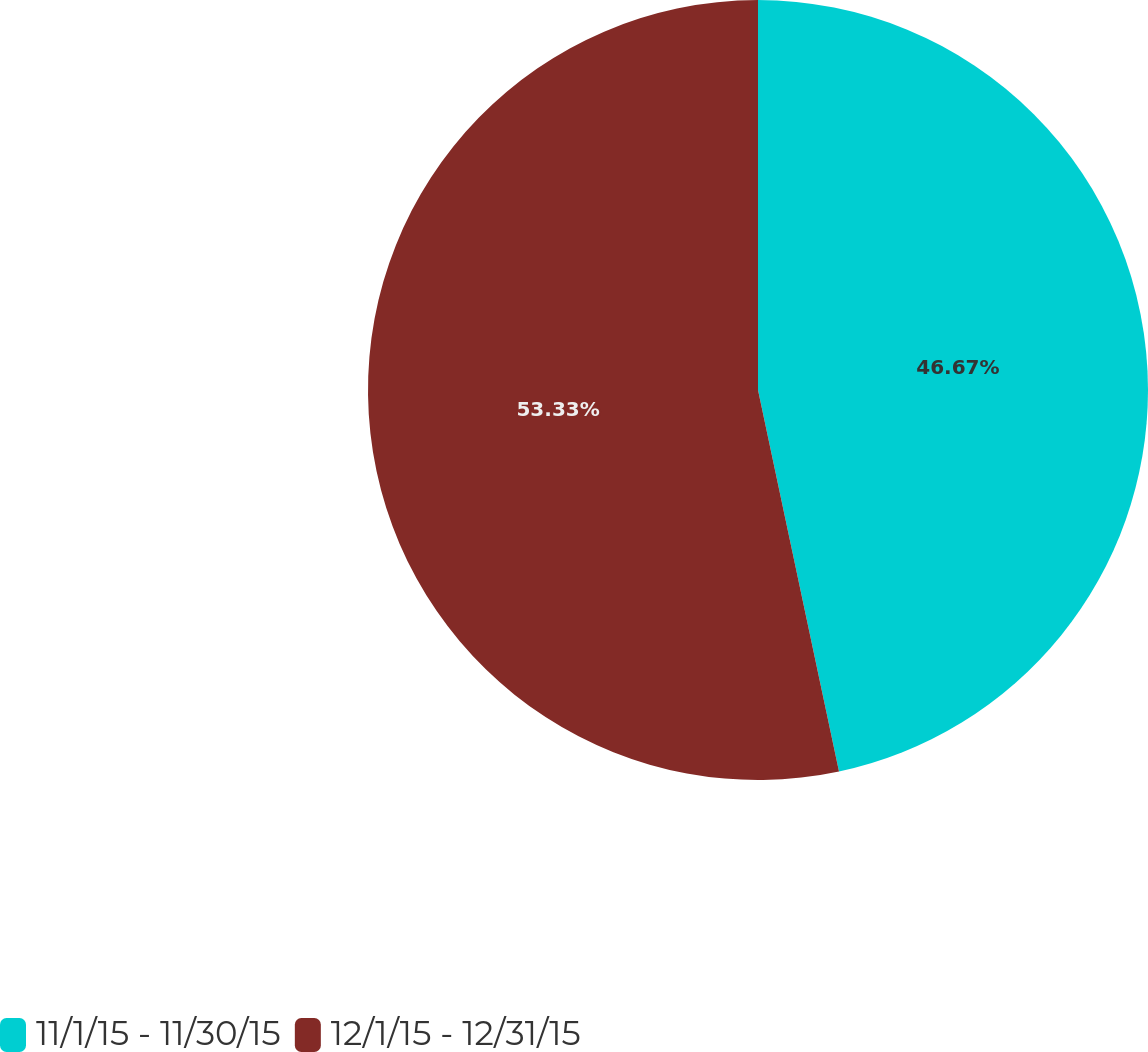Convert chart. <chart><loc_0><loc_0><loc_500><loc_500><pie_chart><fcel>11/1/15 - 11/30/15<fcel>12/1/15 - 12/31/15<nl><fcel>46.67%<fcel>53.33%<nl></chart> 